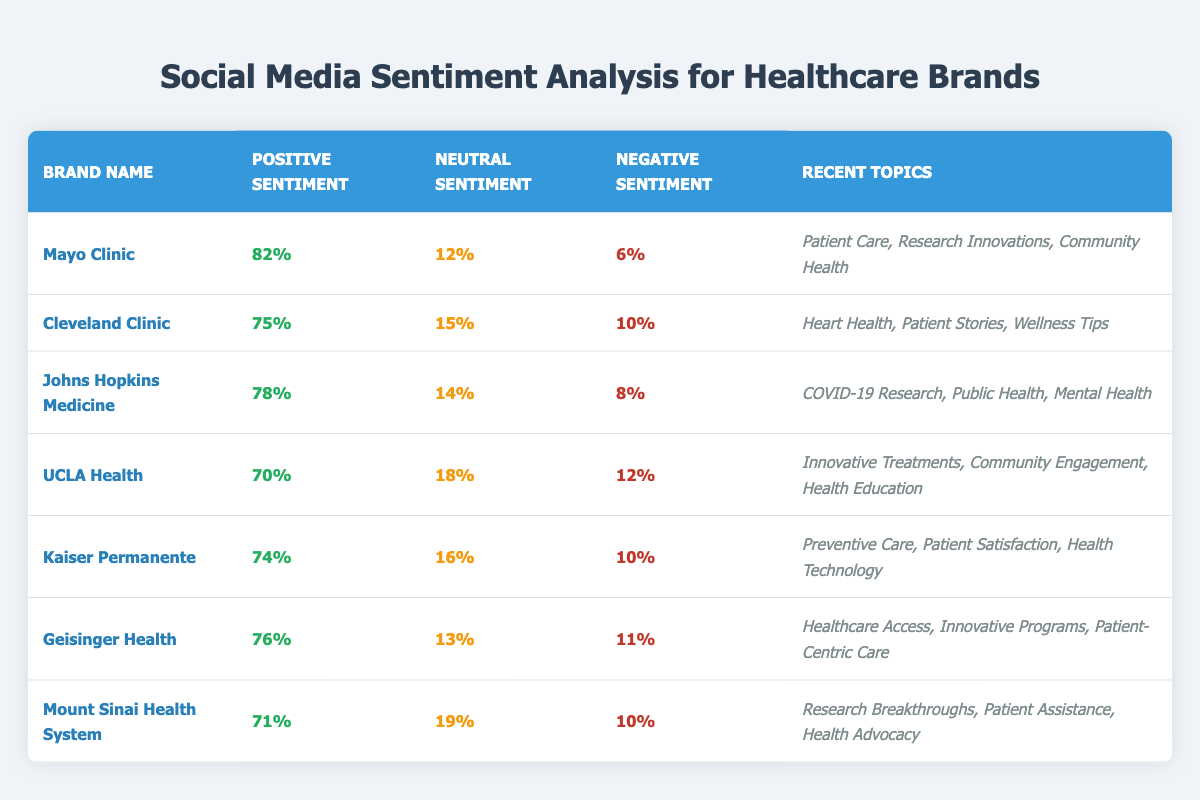What is the positive sentiment percentage for Mayo Clinic? From the table, we can look for the row that contains "Mayo Clinic" and find the corresponding positive sentiment percentage, which is stated directly in the cell. It shows 82%.
Answer: 82% Which brand has the highest negative sentiment percentage? By checking each brand's negative sentiment percentage in the table, we find out that the highest value is 12%, which corresponds to both UCLA Health and Mount Sinai Health System.
Answer: UCLA Health and Mount Sinai Health System What is the total positive sentiment percentage of Cleveland Clinic and Kaiser Permanente? We look for the positive sentiment percentages for both brands in the table: Cleveland Clinic has 75% and Kaiser Permanente has 74%. Adding these gives us 75 + 74 = 149%.
Answer: 149% Is the neutral sentiment percentage for Johns Hopkins Medicine greater than that for UCLA Health? We check the neutral sentiment percentages from the table: Johns Hopkins Medicine has 14%, while UCLA Health has 18%. Since 14% is less than 18%, the statement is false.
Answer: No What is the average positive sentiment percentage among all healthcare brands listed in the table? We first sum the positive sentiment percentages for all brands: 82 + 75 + 78 + 70 + 74 + 76 + 71 = 426. There are 7 brands, so we divide the total by 7, which gives us 426 / 7 ≈ 60.857.
Answer: Approximately 60.86% Which brand's recent topics include "Community Engagement"? We scan through the recent topics for each brand listed in the table and find that "Community Engagement" is mentioned under UCLA Health.
Answer: UCLA Health What is the difference in the positive sentiment percentages between Geisinger Health and Johns Hopkins Medicine? From the table, Geisinger Health has a positive sentiment of 76% while Johns Hopkins Medicine has 78%. The difference can be calculated by subtracting 76 from 78, which results in 2%.
Answer: 2% Which brand has the least amount of neutral sentiment, and what is the percentage? By reviewing the neutral sentiment percentages for each brand, we see that Mayo Clinic has the least at 12%.
Answer: Mayo Clinic, 12% Are there any brands with the same percentage of negative sentiment? We compare the negative sentiment percentages in the table and find that both Cleveland Clinic and Kaiser Permanente have 10%. Therefore, there are brands with the same negative sentiment percentage.
Answer: Yes, Cleveland Clinic and Kaiser Permanente What percentage of positive sentiment does Mount Sinai Health System have when compared to the healthcare brand with the lowest positive sentiment? Mount Sinai Health System has a positive sentiment of 71%. The lowest positive sentiment is from UCLA Health, at 70%. The difference is calculated by subtracting 70 from 71, giving us 1%.
Answer: 1% 